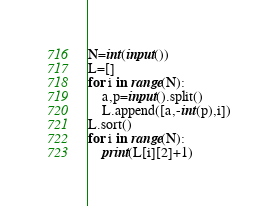<code> <loc_0><loc_0><loc_500><loc_500><_Python_>N=int(input())
L=[]
for i in range(N):
    a,p=input().split()
    L.append([a,-int(p),i])
L.sort()
for i in range(N):
    print(L[i][2]+1)</code> 